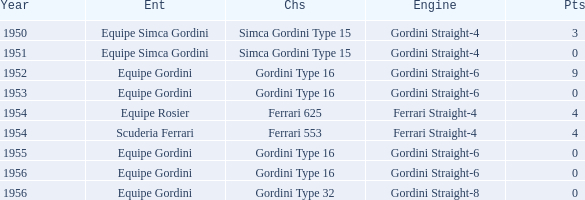Could you parse the entire table as a dict? {'header': ['Year', 'Ent', 'Chs', 'Engine', 'Pts'], 'rows': [['1950', 'Equipe Simca Gordini', 'Simca Gordini Type 15', 'Gordini Straight-4', '3'], ['1951', 'Equipe Simca Gordini', 'Simca Gordini Type 15', 'Gordini Straight-4', '0'], ['1952', 'Equipe Gordini', 'Gordini Type 16', 'Gordini Straight-6', '9'], ['1953', 'Equipe Gordini', 'Gordini Type 16', 'Gordini Straight-6', '0'], ['1954', 'Equipe Rosier', 'Ferrari 625', 'Ferrari Straight-4', '4'], ['1954', 'Scuderia Ferrari', 'Ferrari 553', 'Ferrari Straight-4', '4'], ['1955', 'Equipe Gordini', 'Gordini Type 16', 'Gordini Straight-6', '0'], ['1956', 'Equipe Gordini', 'Gordini Type 16', 'Gordini Straight-6', '0'], ['1956', 'Equipe Gordini', 'Gordini Type 32', 'Gordini Straight-8', '0']]} What chassis has smaller than 9 points by Equipe Rosier? Ferrari 625. 